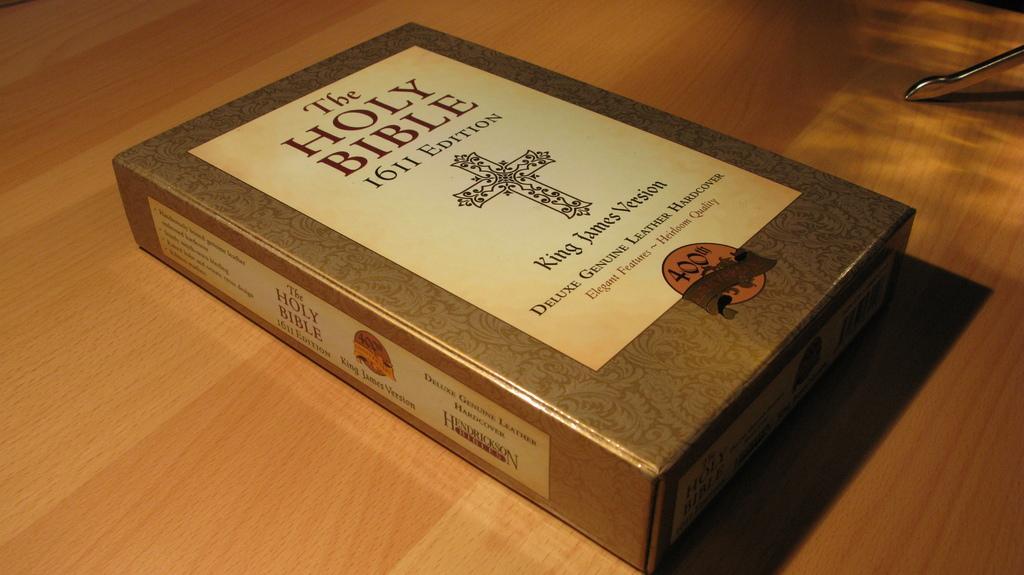Can you describe this image briefly? In this image I can see a box is placed on a wooden surface. On this box there is some text. In the top right-hand corner, there is a metal object. 